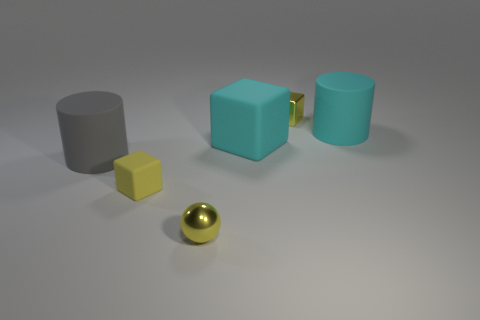What shape is the tiny yellow metallic thing right of the cyan matte cube?
Offer a very short reply. Cube. What material is the ball that is the same color as the metallic cube?
Keep it short and to the point. Metal. The metal sphere in front of the shiny object behind the large cyan rubber cylinder is what color?
Provide a succinct answer. Yellow. Do the gray rubber thing and the cyan cube have the same size?
Offer a terse response. Yes. There is another tiny thing that is the same shape as the yellow matte thing; what is its material?
Offer a very short reply. Metal. What number of rubber blocks are the same size as the cyan rubber cylinder?
Keep it short and to the point. 1. There is a tiny block that is made of the same material as the big cyan cylinder; what is its color?
Offer a very short reply. Yellow. Is the number of yellow matte blocks less than the number of tiny red rubber balls?
Offer a very short reply. No. What number of cyan things are metallic blocks or large objects?
Ensure brevity in your answer.  2. What number of matte things are both on the left side of the small yellow sphere and on the right side of the tiny metal block?
Your answer should be compact. 0. 